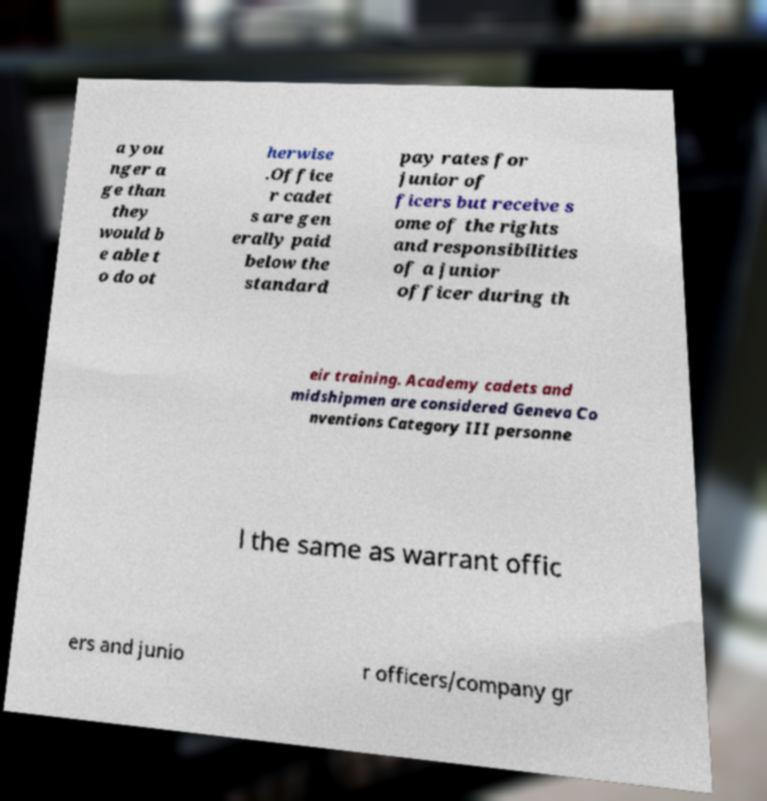I need the written content from this picture converted into text. Can you do that? a you nger a ge than they would b e able t o do ot herwise .Office r cadet s are gen erally paid below the standard pay rates for junior of ficers but receive s ome of the rights and responsibilities of a junior officer during th eir training. Academy cadets and midshipmen are considered Geneva Co nventions Category III personne l the same as warrant offic ers and junio r officers/company gr 